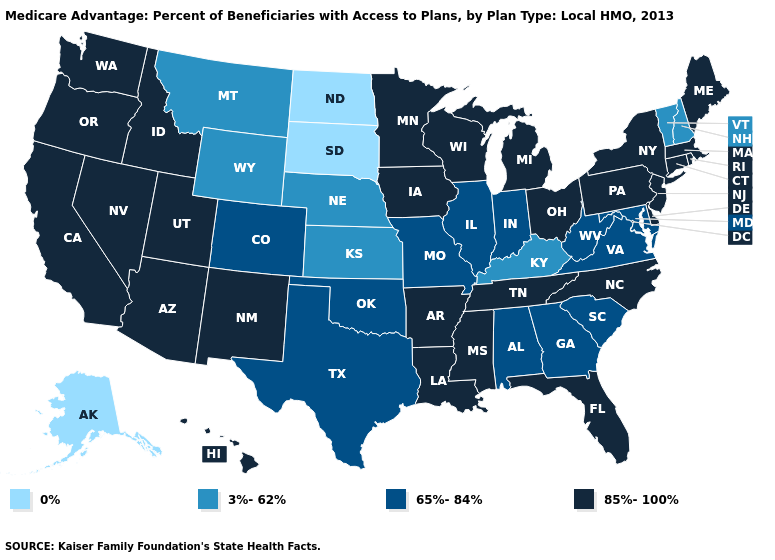What is the highest value in states that border North Carolina?
Give a very brief answer. 85%-100%. Does Florida have the same value as Illinois?
Answer briefly. No. What is the value of Illinois?
Give a very brief answer. 65%-84%. What is the value of West Virginia?
Short answer required. 65%-84%. Name the states that have a value in the range 85%-100%?
Give a very brief answer. Arkansas, Arizona, California, Connecticut, Delaware, Florida, Hawaii, Iowa, Idaho, Louisiana, Massachusetts, Maine, Michigan, Minnesota, Mississippi, North Carolina, New Jersey, New Mexico, Nevada, New York, Ohio, Oregon, Pennsylvania, Rhode Island, Tennessee, Utah, Washington, Wisconsin. What is the value of Wisconsin?
Answer briefly. 85%-100%. Name the states that have a value in the range 65%-84%?
Give a very brief answer. Alabama, Colorado, Georgia, Illinois, Indiana, Maryland, Missouri, Oklahoma, South Carolina, Texas, Virginia, West Virginia. What is the value of New Jersey?
Write a very short answer. 85%-100%. Which states have the lowest value in the USA?
Keep it brief. Alaska, North Dakota, South Dakota. Is the legend a continuous bar?
Concise answer only. No. What is the value of Texas?
Answer briefly. 65%-84%. Does Idaho have a higher value than Massachusetts?
Write a very short answer. No. Name the states that have a value in the range 85%-100%?
Short answer required. Arkansas, Arizona, California, Connecticut, Delaware, Florida, Hawaii, Iowa, Idaho, Louisiana, Massachusetts, Maine, Michigan, Minnesota, Mississippi, North Carolina, New Jersey, New Mexico, Nevada, New York, Ohio, Oregon, Pennsylvania, Rhode Island, Tennessee, Utah, Washington, Wisconsin. Which states hav the highest value in the West?
Write a very short answer. Arizona, California, Hawaii, Idaho, New Mexico, Nevada, Oregon, Utah, Washington. Is the legend a continuous bar?
Be succinct. No. 